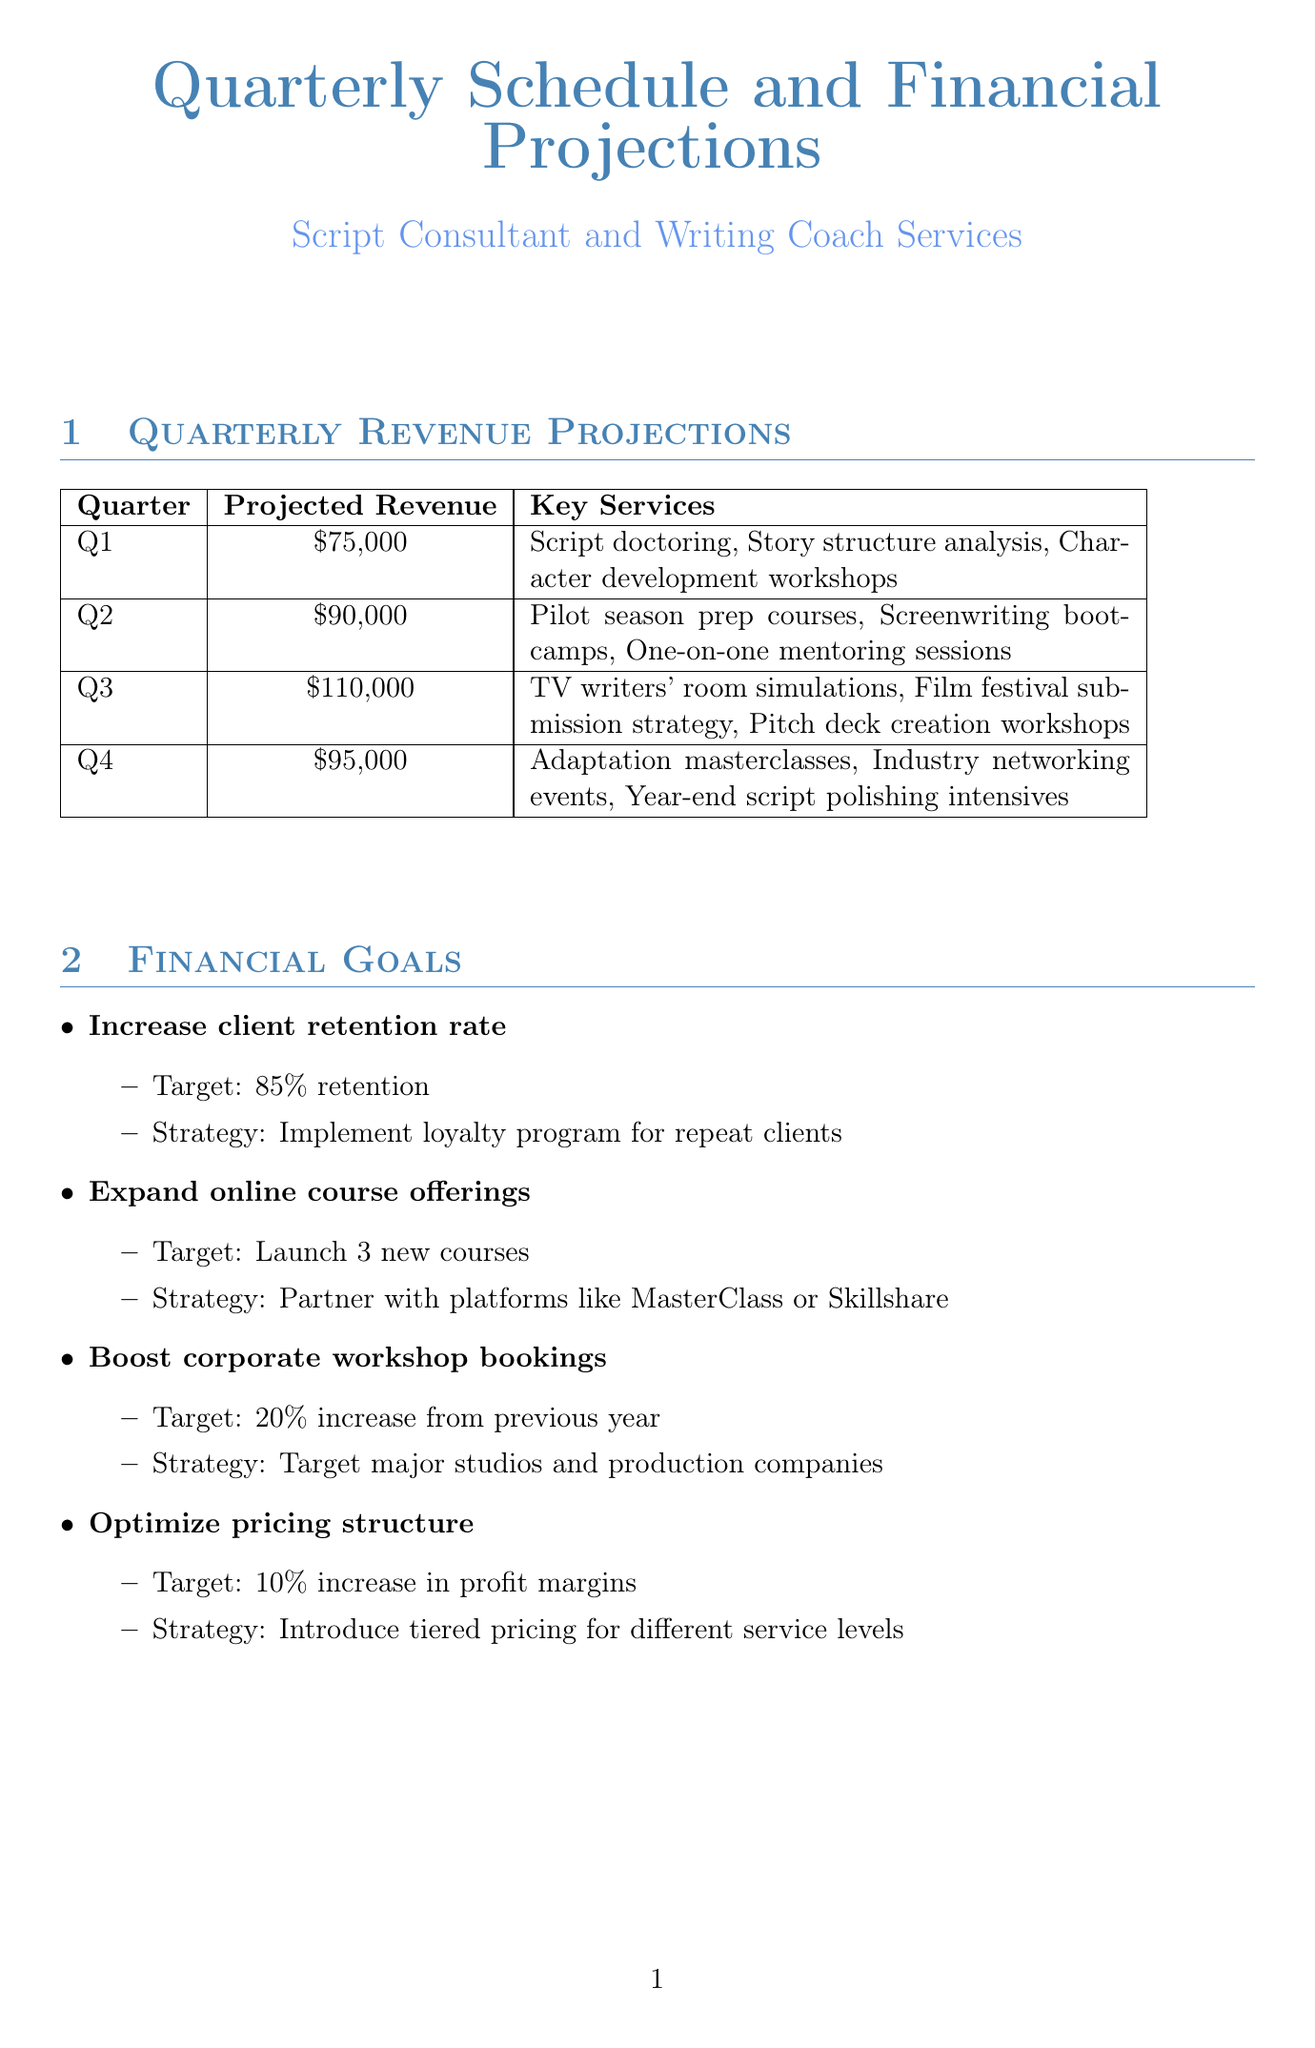What is the projected revenue for Q2? The projected revenue for Q2 is specifically stated in the document, which is $90,000.
Answer: $90,000 Which key service is offered in Q3? The document lists the key services offered in Q3, one of which is "TV writers' room simulations."
Answer: TV writers' room simulations What is the target for increasing client retention rate? The document indicates a target for client retention rate which is "85% retention."
Answer: 85% retention What percentage of revenue is allocated to Operational Costs? The document specifies that Operational Costs are allocated "30% of revenue."
Answer: 30% of revenue Which partner collaborates on a mentorship program for emerging screenwriters? The document indicates that The Black List is the partner for a mentorship program.
Answer: The Black List What is the projected revenue total for all four quarters? The total is calculated by summing the projected revenues: $75,000 + $90,000 + $110,000 + $95,000, which equals $370,000.
Answer: $370,000 What strategy is proposed for expanding online course offerings? According to the document, the strategy is to "Partner with platforms like MasterClass or Skillshare."
Answer: Partner with platforms like MasterClass or Skillshare How many new courses are planned to be launched? The document states that the target is to launch "3 new courses."
Answer: 3 new courses 